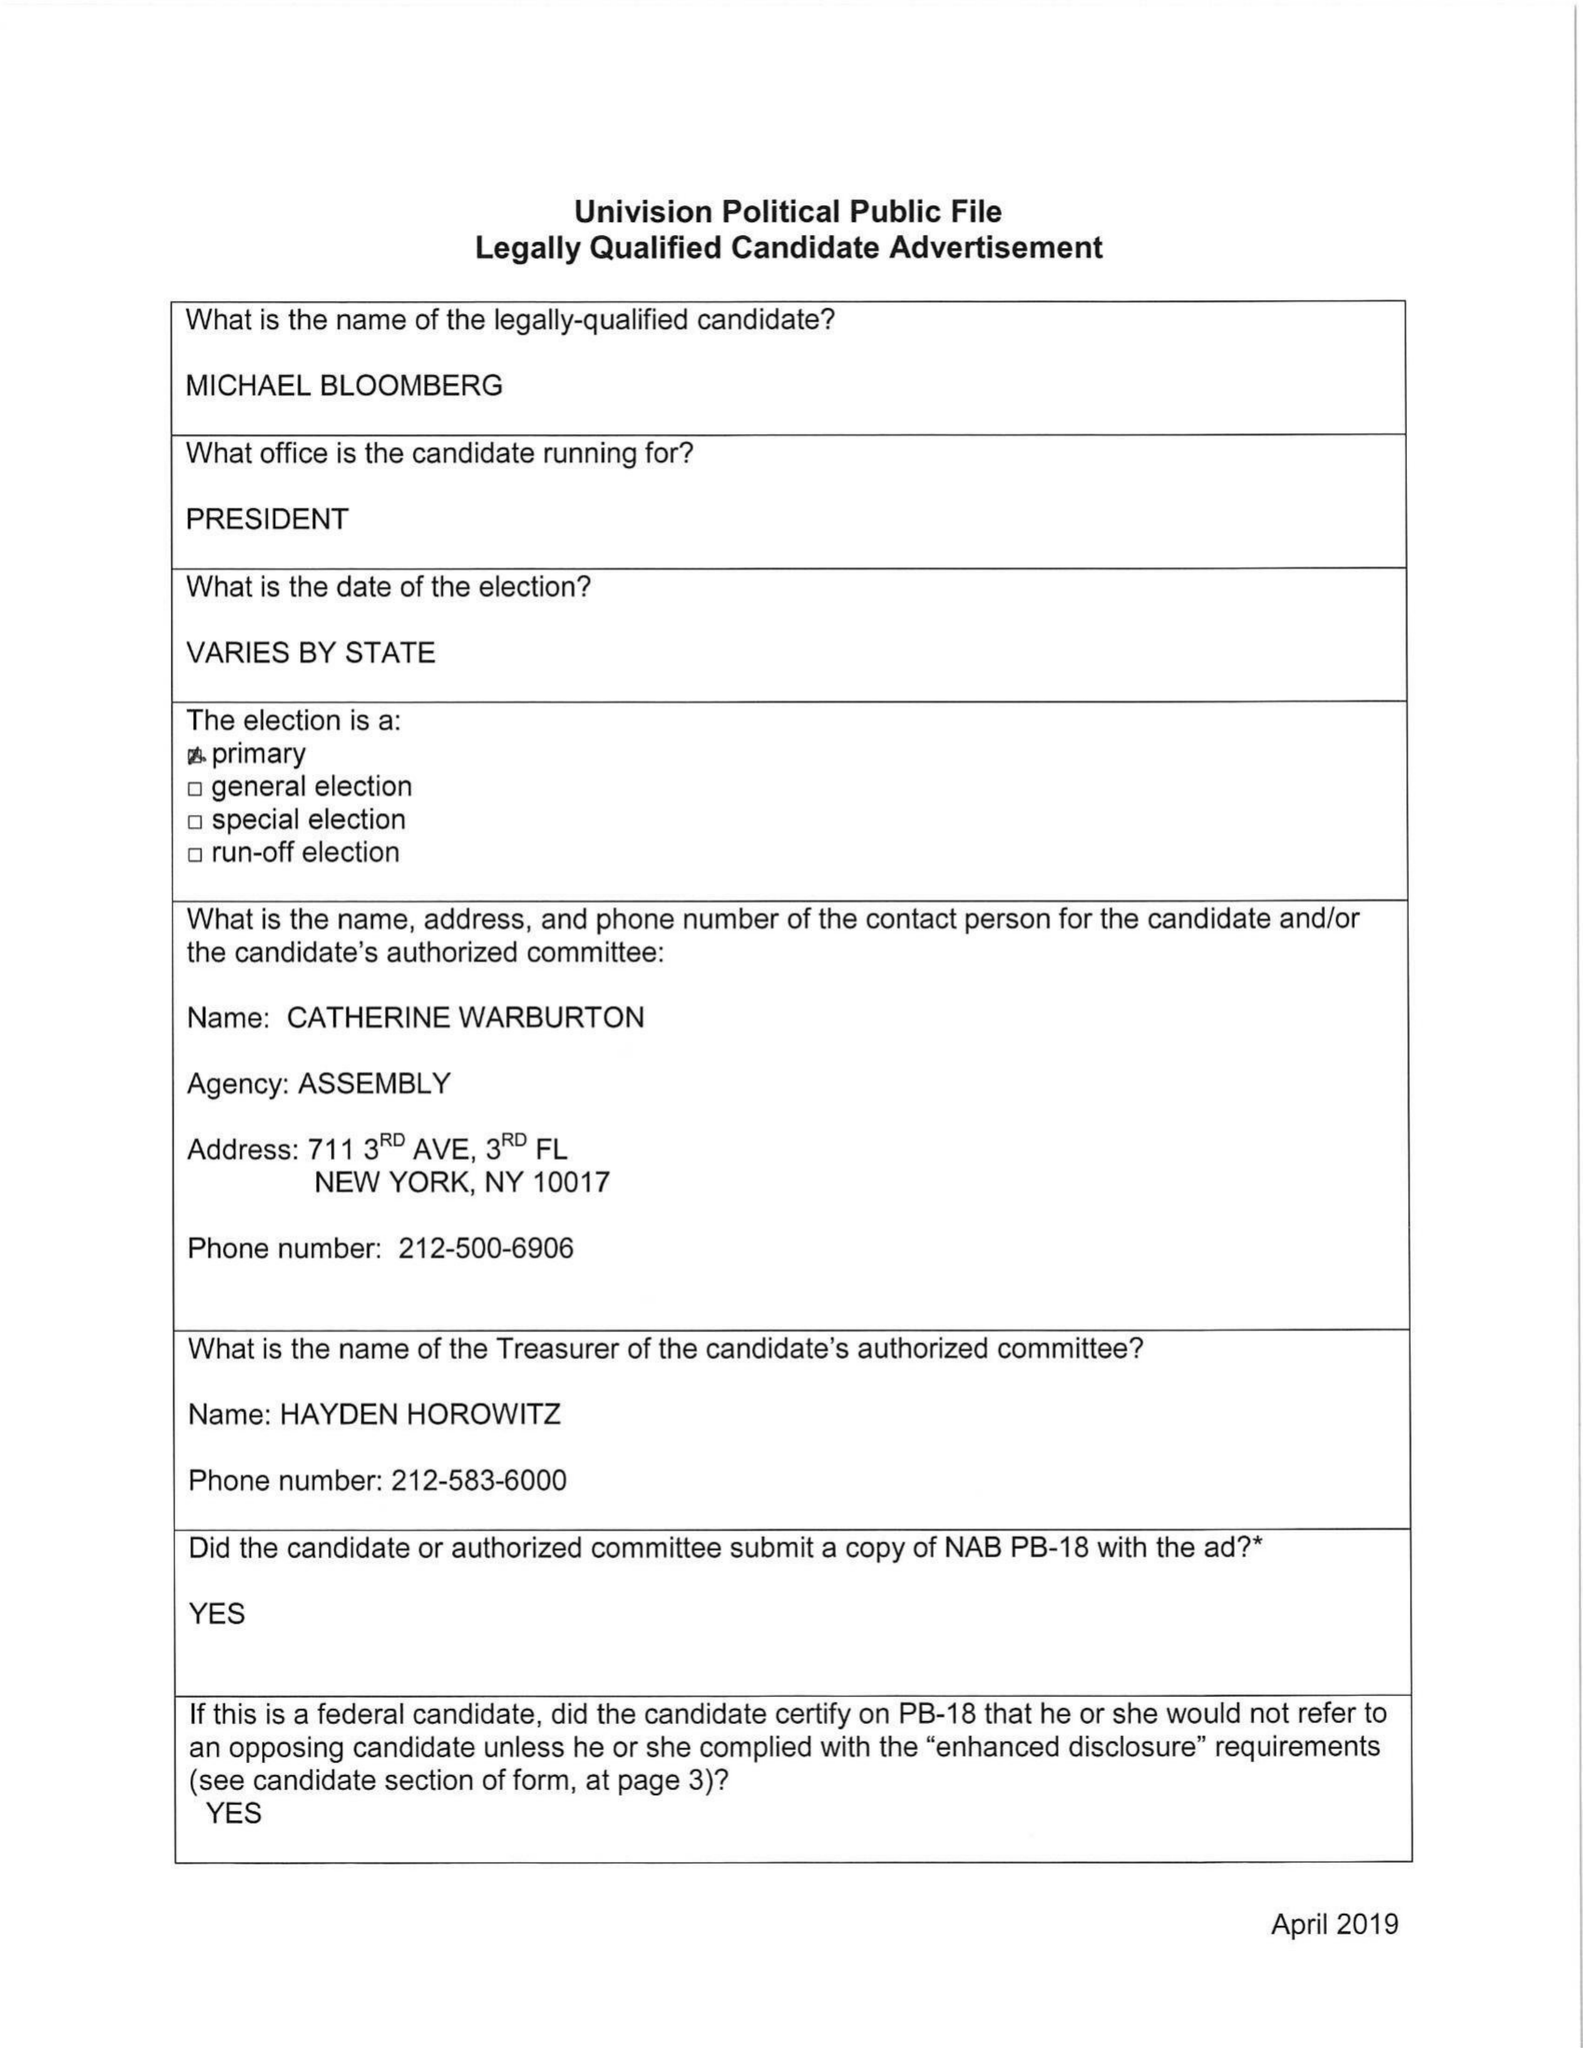What is the value for the flight_from?
Answer the question using a single word or phrase. None 